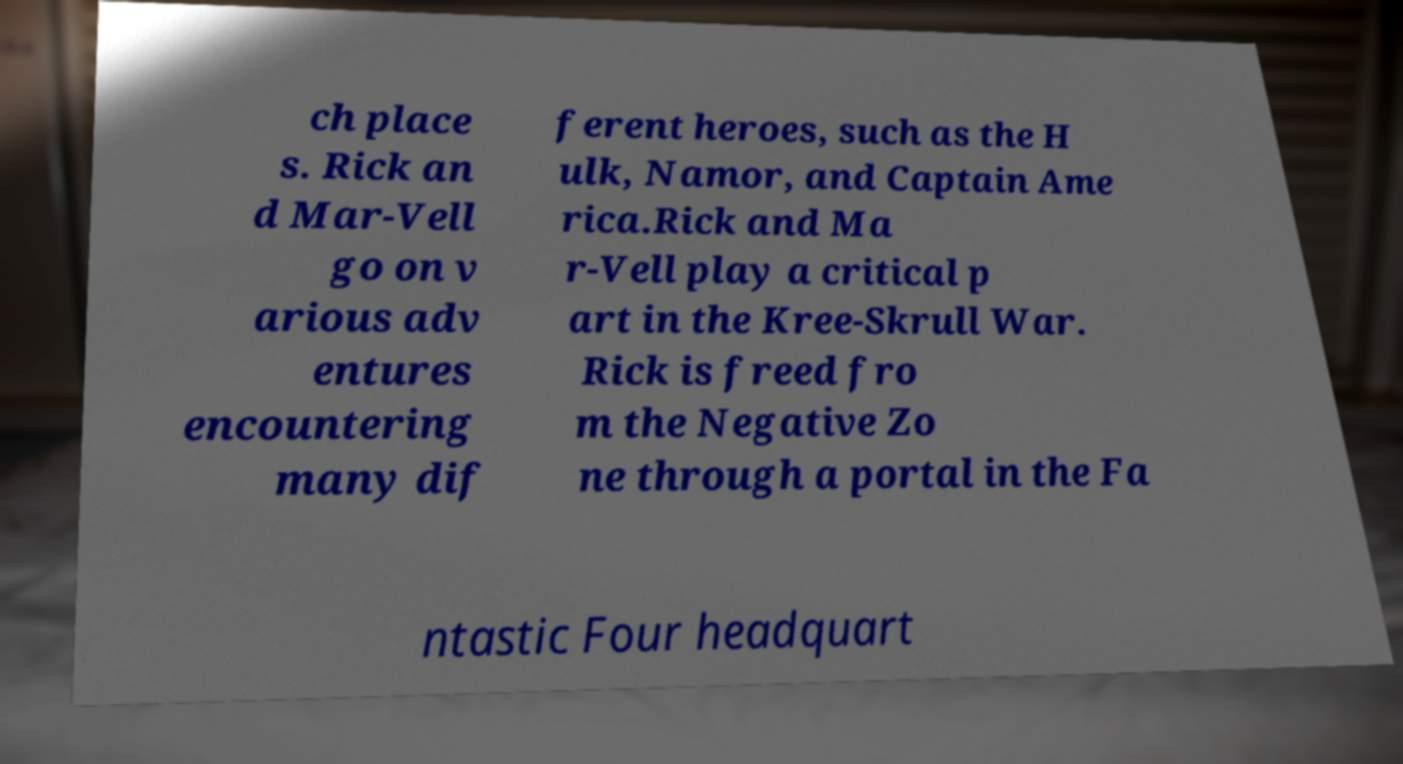There's text embedded in this image that I need extracted. Can you transcribe it verbatim? ch place s. Rick an d Mar-Vell go on v arious adv entures encountering many dif ferent heroes, such as the H ulk, Namor, and Captain Ame rica.Rick and Ma r-Vell play a critical p art in the Kree-Skrull War. Rick is freed fro m the Negative Zo ne through a portal in the Fa ntastic Four headquart 